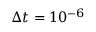<formula> <loc_0><loc_0><loc_500><loc_500>\Delta t = 1 0 ^ { - 6 }</formula> 